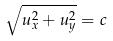<formula> <loc_0><loc_0><loc_500><loc_500>\sqrt { u _ { x } ^ { 2 } + u _ { y } ^ { 2 } } = c</formula> 